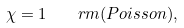Convert formula to latex. <formula><loc_0><loc_0><loc_500><loc_500>\chi = 1 \quad r m { ( P o i s s o n ) , }</formula> 